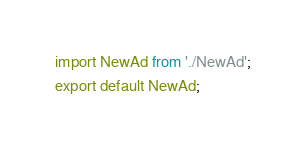Convert code to text. <code><loc_0><loc_0><loc_500><loc_500><_JavaScript_>import NewAd from './NewAd';

export default NewAd;</code> 